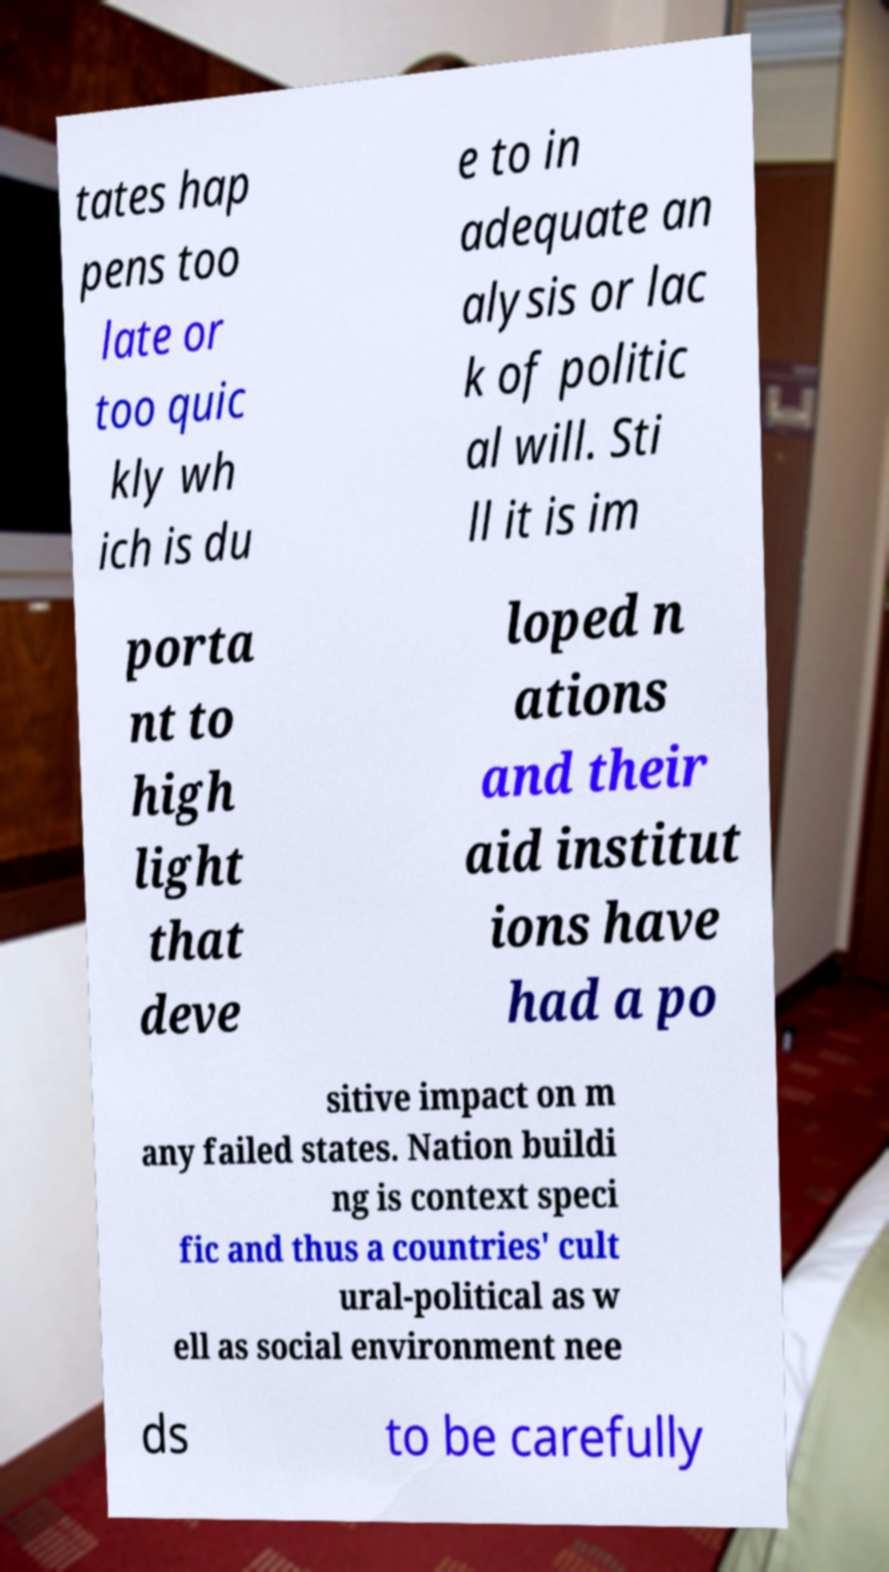Can you accurately transcribe the text from the provided image for me? tates hap pens too late or too quic kly wh ich is du e to in adequate an alysis or lac k of politic al will. Sti ll it is im porta nt to high light that deve loped n ations and their aid institut ions have had a po sitive impact on m any failed states. Nation buildi ng is context speci fic and thus a countries' cult ural-political as w ell as social environment nee ds to be carefully 